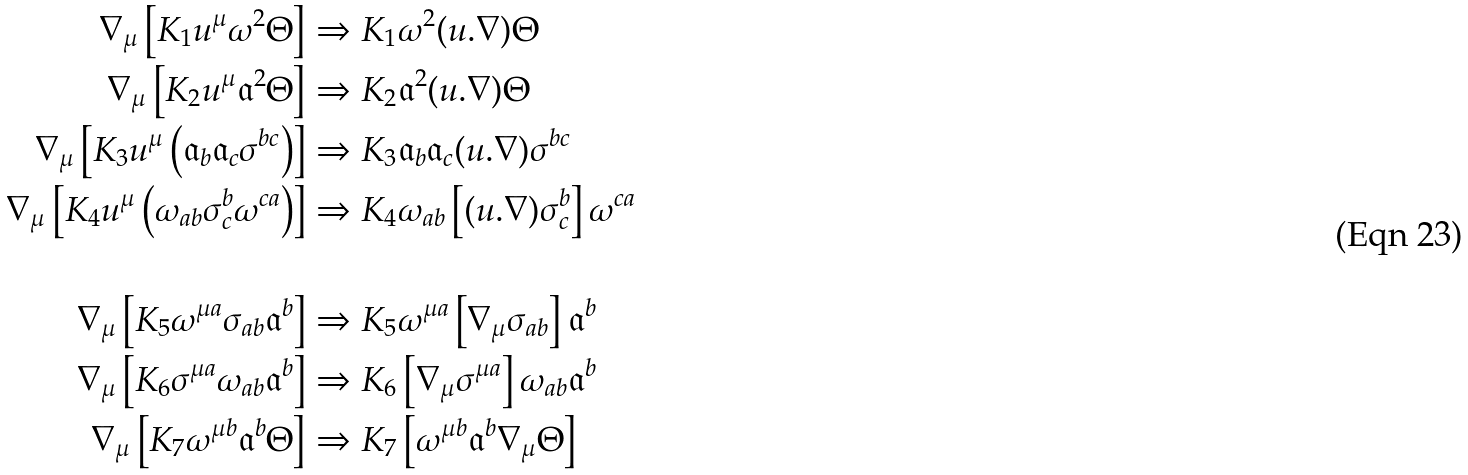Convert formula to latex. <formula><loc_0><loc_0><loc_500><loc_500>\nabla _ { \mu } \left [ K _ { 1 } u ^ { \mu } \omega ^ { 2 } \Theta \right ] & \Rightarrow K _ { 1 } \omega ^ { 2 } ( u . \nabla ) \Theta \\ \nabla _ { \mu } \left [ K _ { 2 } u ^ { \mu } { \mathfrak a } ^ { 2 } \Theta \right ] & \Rightarrow K _ { 2 } { \mathfrak a } ^ { 2 } ( u . \nabla ) \Theta \\ \nabla _ { \mu } \left [ K _ { 3 } u ^ { \mu } \left ( { \mathfrak a } _ { b } { \mathfrak a } _ { c } \sigma ^ { b c } \right ) \right ] & \Rightarrow K _ { 3 } { \mathfrak a } _ { b } { \mathfrak a } _ { c } ( u . \nabla ) \sigma ^ { b c } \\ \nabla _ { \mu } \left [ K _ { 4 } u ^ { \mu } \left ( \omega _ { a b } \sigma ^ { b } _ { c } \omega ^ { c a } \right ) \right ] & \Rightarrow K _ { 4 } \omega _ { a b } \left [ ( u . \nabla ) \sigma ^ { b } _ { c } \right ] \omega ^ { c a } \\ \\ \nabla _ { \mu } \left [ K _ { 5 } \omega ^ { \mu a } \sigma _ { a b } { \mathfrak a } ^ { b } \right ] & \Rightarrow K _ { 5 } \omega ^ { \mu a } \left [ \nabla _ { \mu } \sigma _ { a b } \right ] { \mathfrak a } ^ { b } \\ \nabla _ { \mu } \left [ K _ { 6 } \sigma ^ { \mu a } \omega _ { a b } { \mathfrak a } ^ { b } \right ] & \Rightarrow K _ { 6 } \left [ \nabla _ { \mu } \sigma ^ { \mu a } \right ] \omega _ { a b } { \mathfrak a } ^ { b } \\ \nabla _ { \mu } \left [ K _ { 7 } \omega ^ { \mu b } { \mathfrak a } ^ { b } \Theta \right ] & \Rightarrow K _ { 7 } \left [ \omega ^ { \mu b } { \mathfrak a } ^ { b } \nabla _ { \mu } \Theta \right ] \\</formula> 